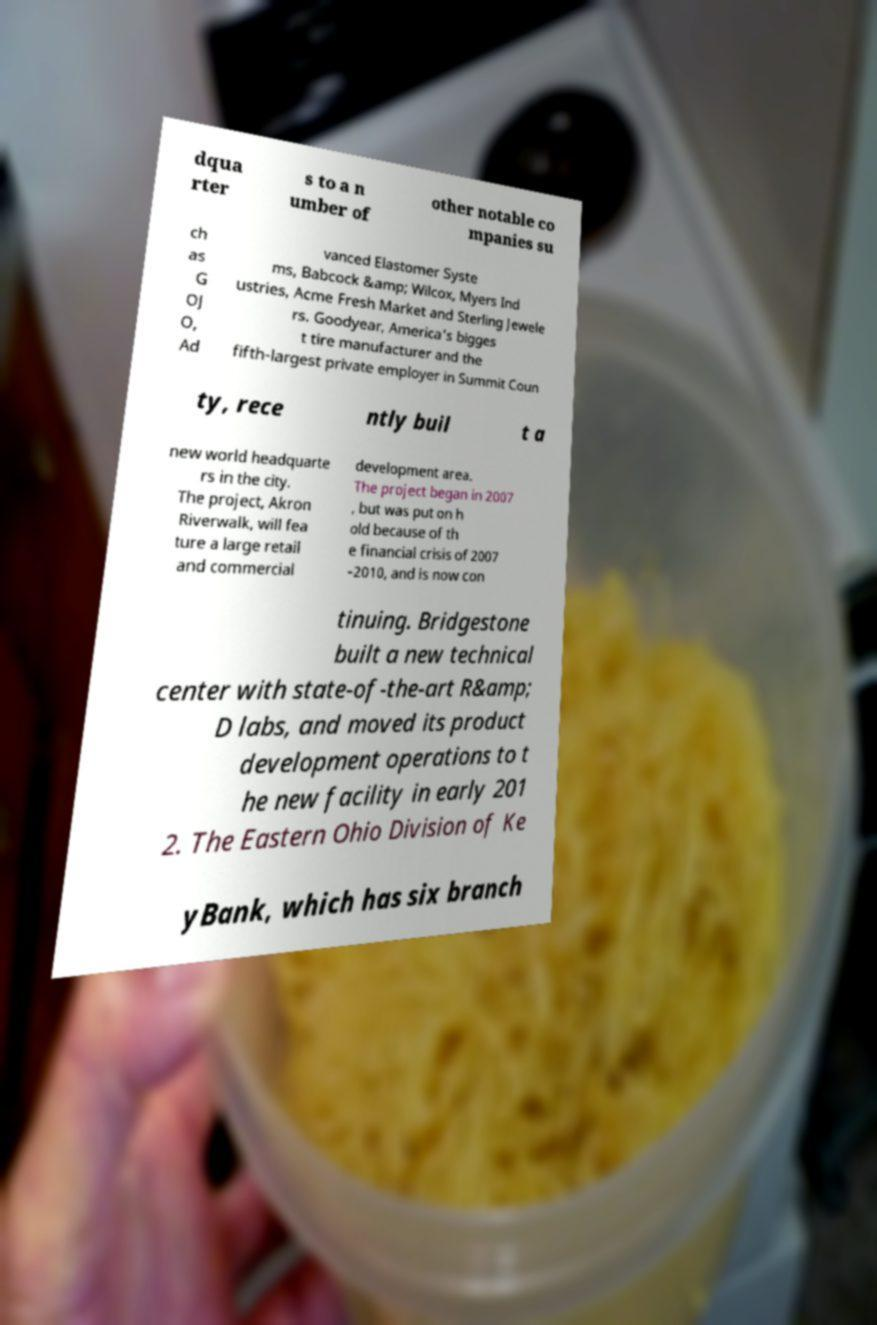I need the written content from this picture converted into text. Can you do that? dqua rter s to a n umber of other notable co mpanies su ch as G OJ O, Ad vanced Elastomer Syste ms, Babcock &amp; Wilcox, Myers Ind ustries, Acme Fresh Market and Sterling Jewele rs. Goodyear, America's bigges t tire manufacturer and the fifth-largest private employer in Summit Coun ty, rece ntly buil t a new world headquarte rs in the city. The project, Akron Riverwalk, will fea ture a large retail and commercial development area. The project began in 2007 , but was put on h old because of th e financial crisis of 2007 –2010, and is now con tinuing. Bridgestone built a new technical center with state-of-the-art R&amp; D labs, and moved its product development operations to t he new facility in early 201 2. The Eastern Ohio Division of Ke yBank, which has six branch 